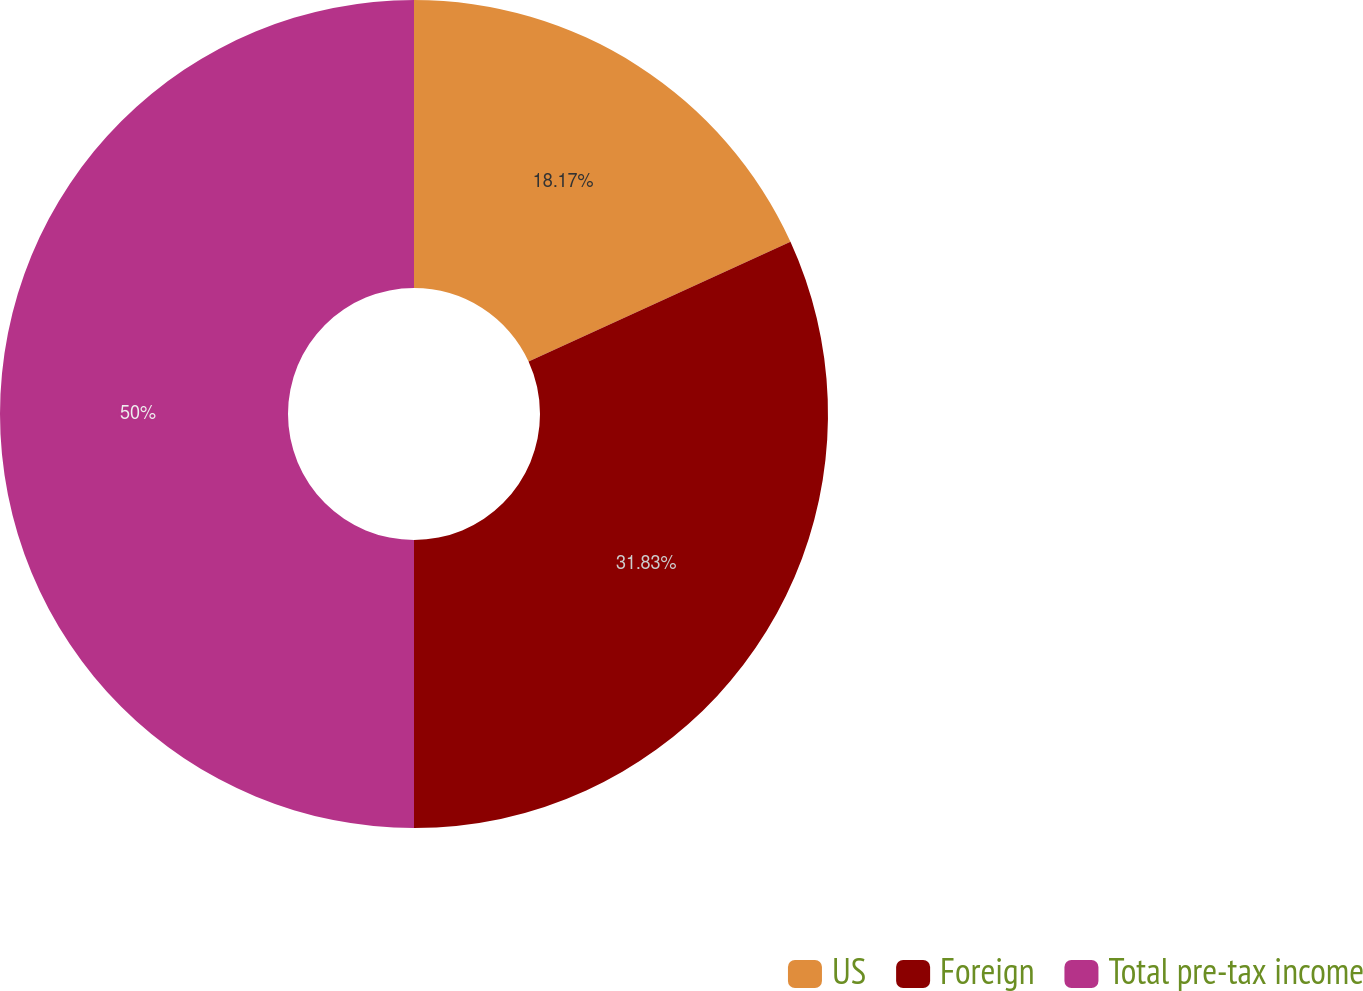Convert chart. <chart><loc_0><loc_0><loc_500><loc_500><pie_chart><fcel>US<fcel>Foreign<fcel>Total pre-tax income<nl><fcel>18.17%<fcel>31.83%<fcel>50.0%<nl></chart> 